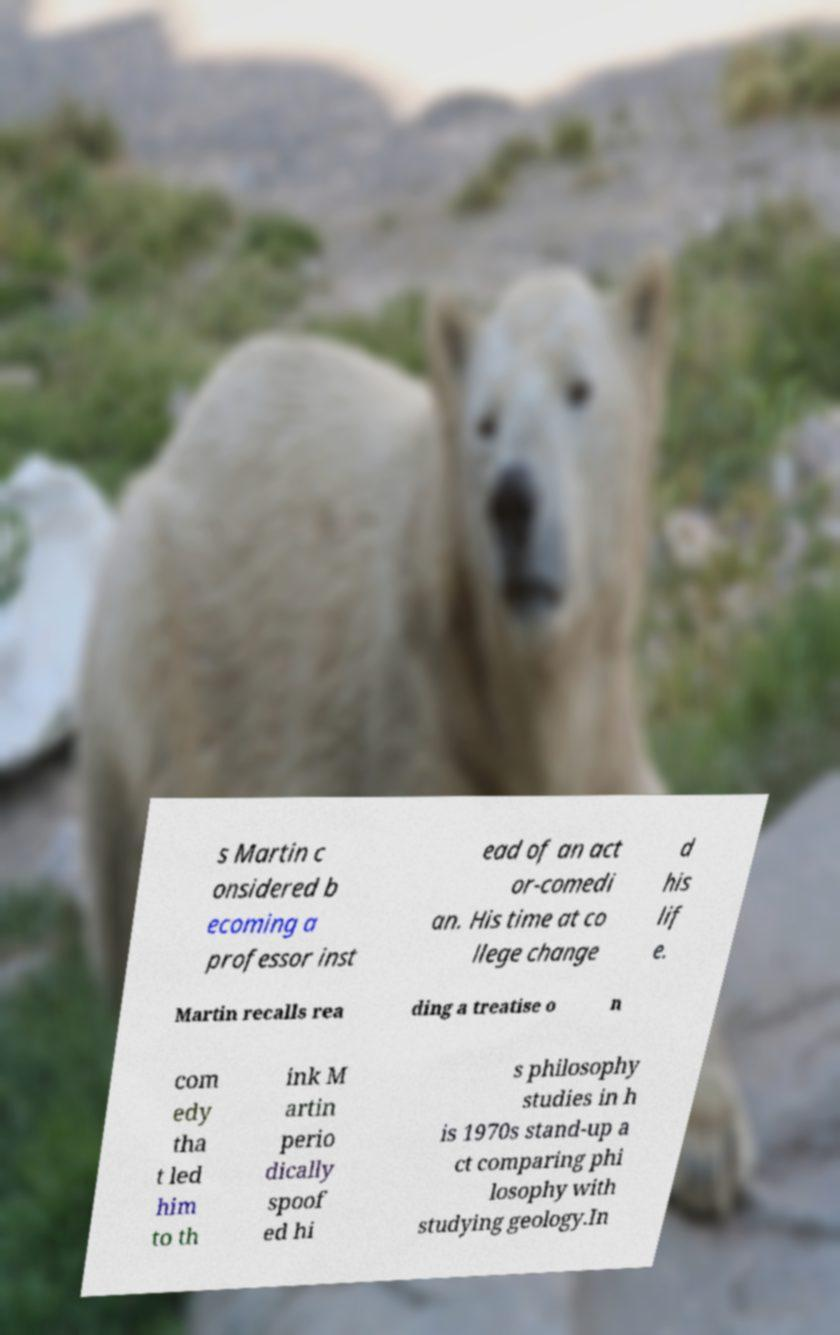I need the written content from this picture converted into text. Can you do that? s Martin c onsidered b ecoming a professor inst ead of an act or-comedi an. His time at co llege change d his lif e. Martin recalls rea ding a treatise o n com edy tha t led him to th ink M artin perio dically spoof ed hi s philosophy studies in h is 1970s stand-up a ct comparing phi losophy with studying geology.In 